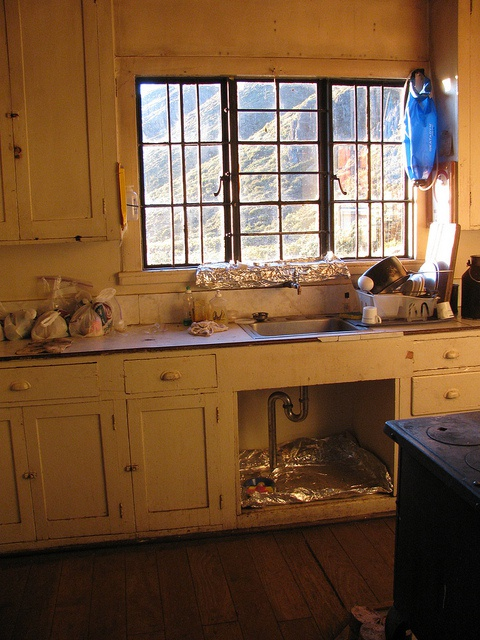Describe the objects in this image and their specific colors. I can see sink in maroon, gray, and brown tones, cup in maroon, gray, tan, and darkgray tones, cup in maroon, tan, and olive tones, and spoon in maroon, tan, and gray tones in this image. 